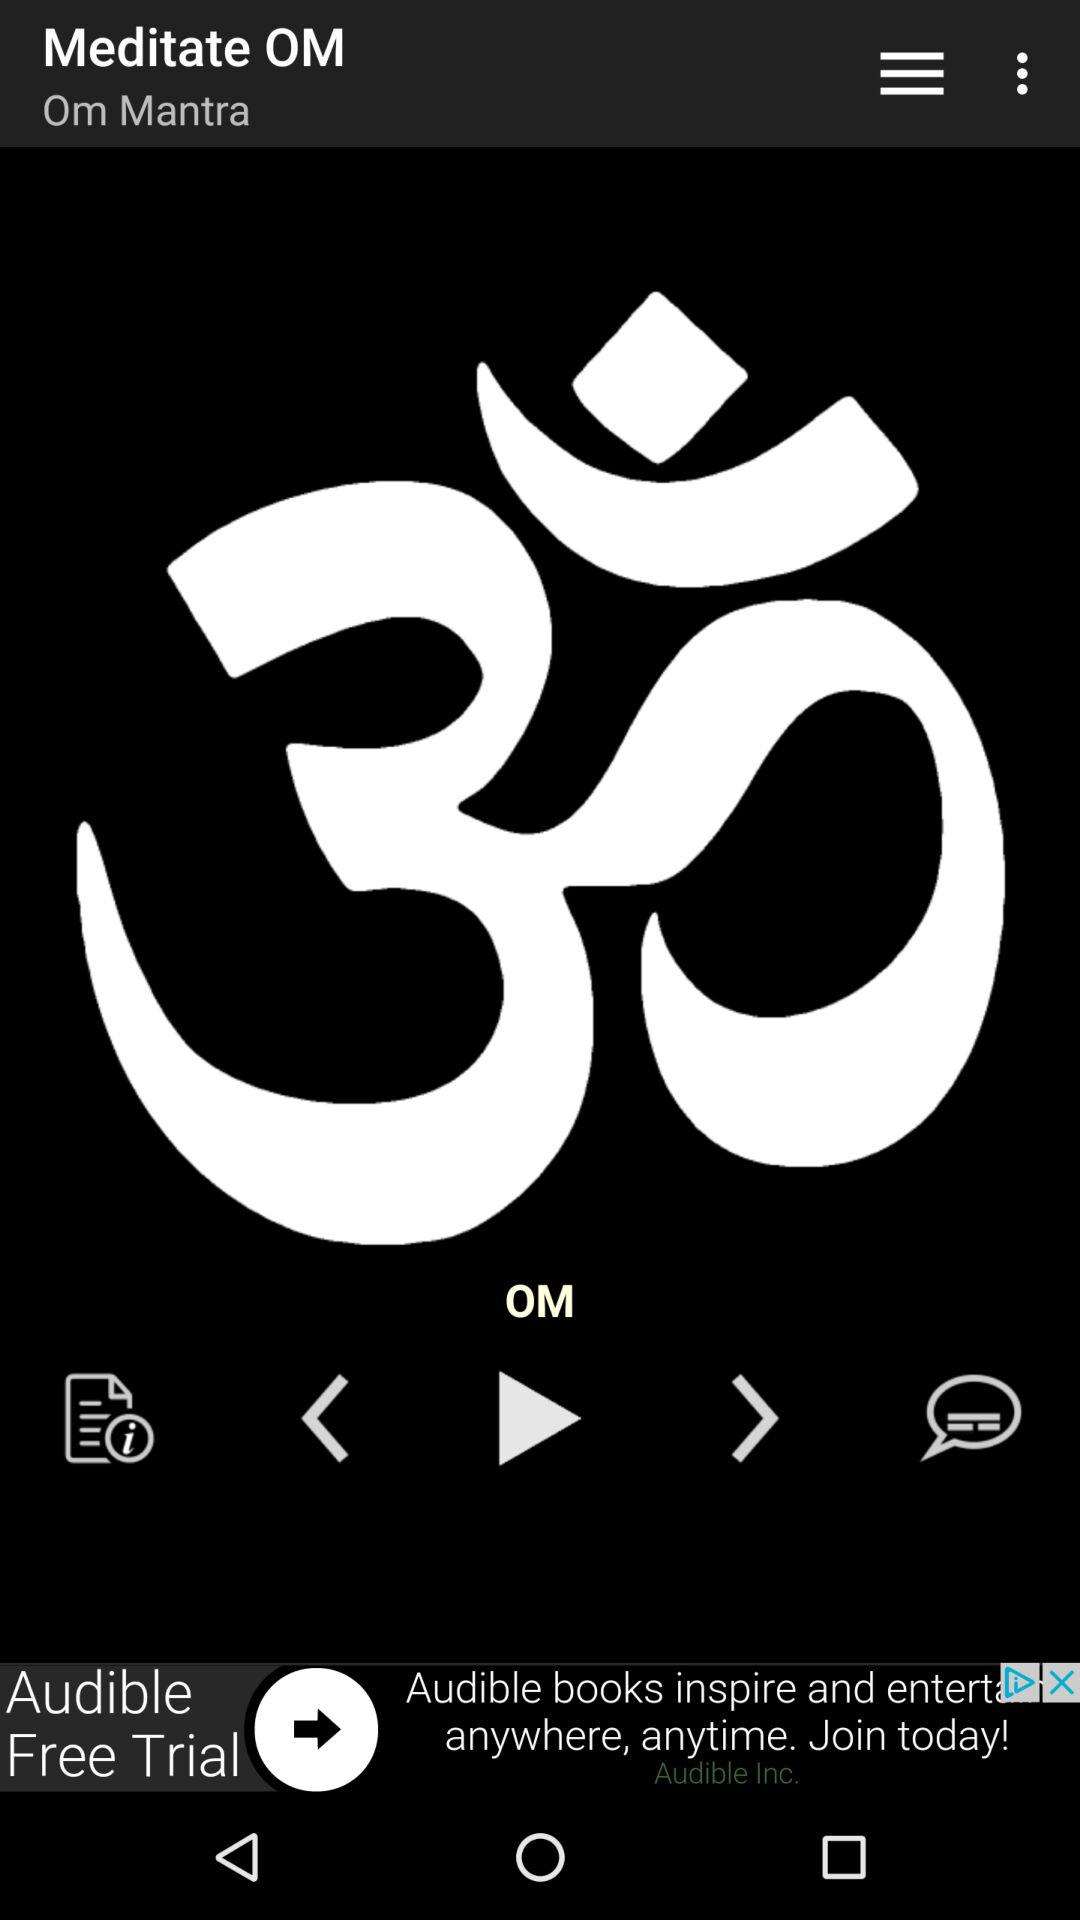Which song is currently played? The currently playing song is "OM". 